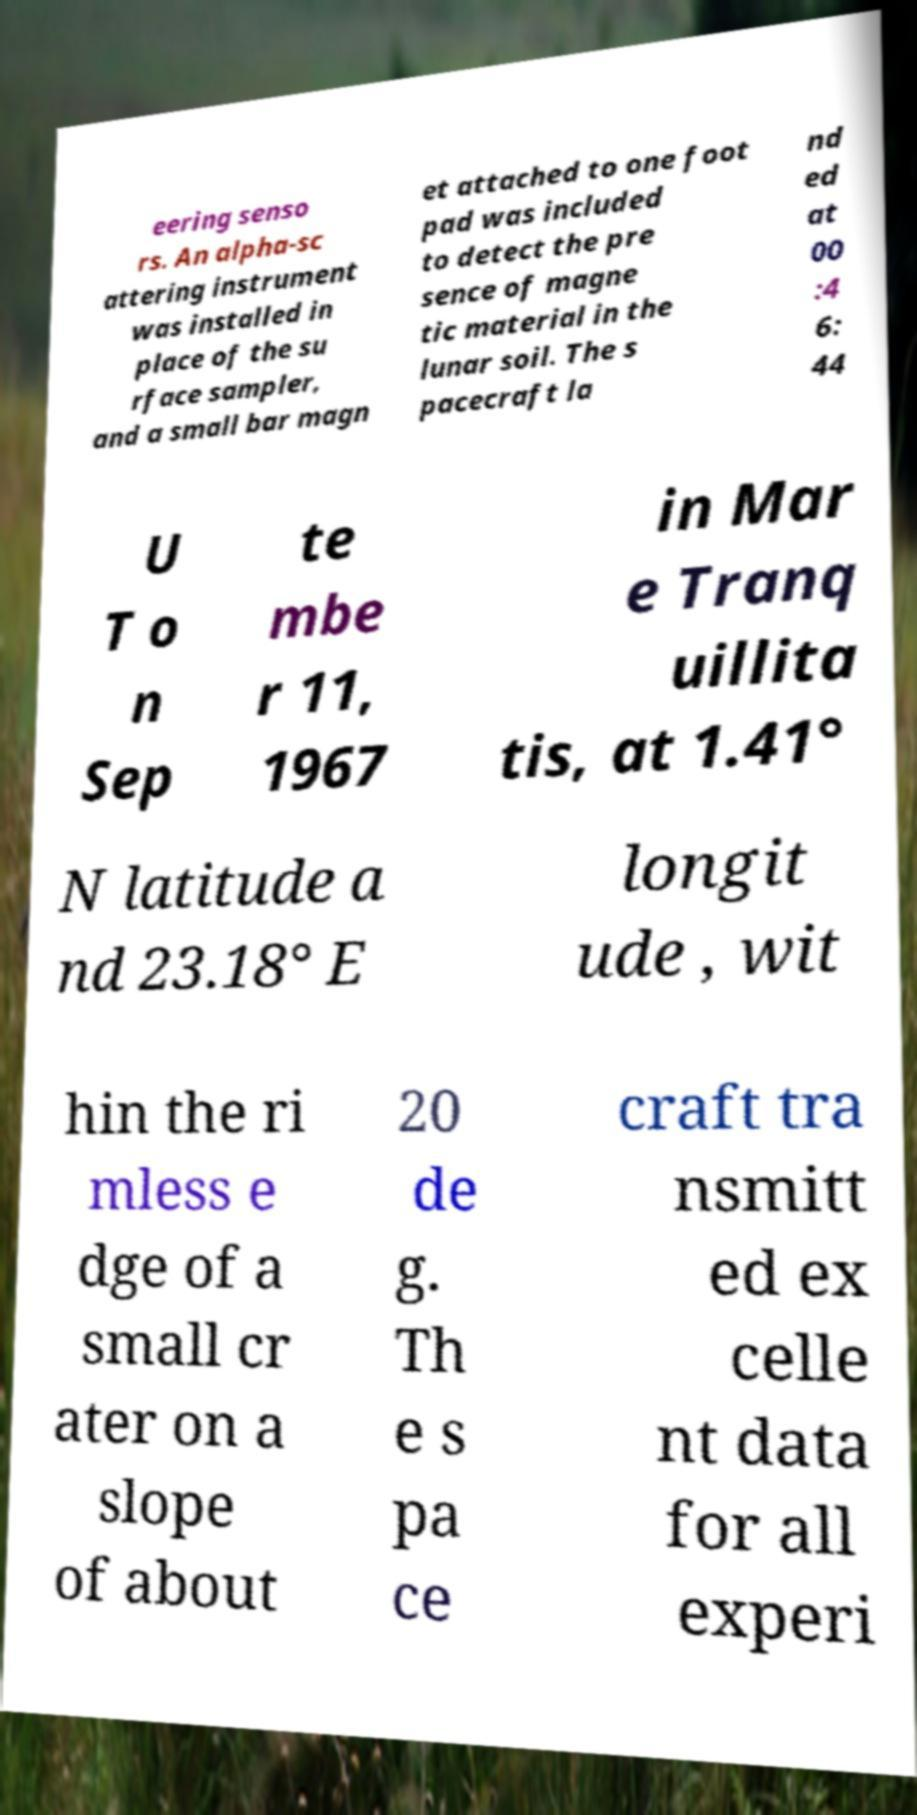Could you assist in decoding the text presented in this image and type it out clearly? eering senso rs. An alpha-sc attering instrument was installed in place of the su rface sampler, and a small bar magn et attached to one foot pad was included to detect the pre sence of magne tic material in the lunar soil. The s pacecraft la nd ed at 00 :4 6: 44 U T o n Sep te mbe r 11, 1967 in Mar e Tranq uillita tis, at 1.41° N latitude a nd 23.18° E longit ude , wit hin the ri mless e dge of a small cr ater on a slope of about 20 de g. Th e s pa ce craft tra nsmitt ed ex celle nt data for all experi 